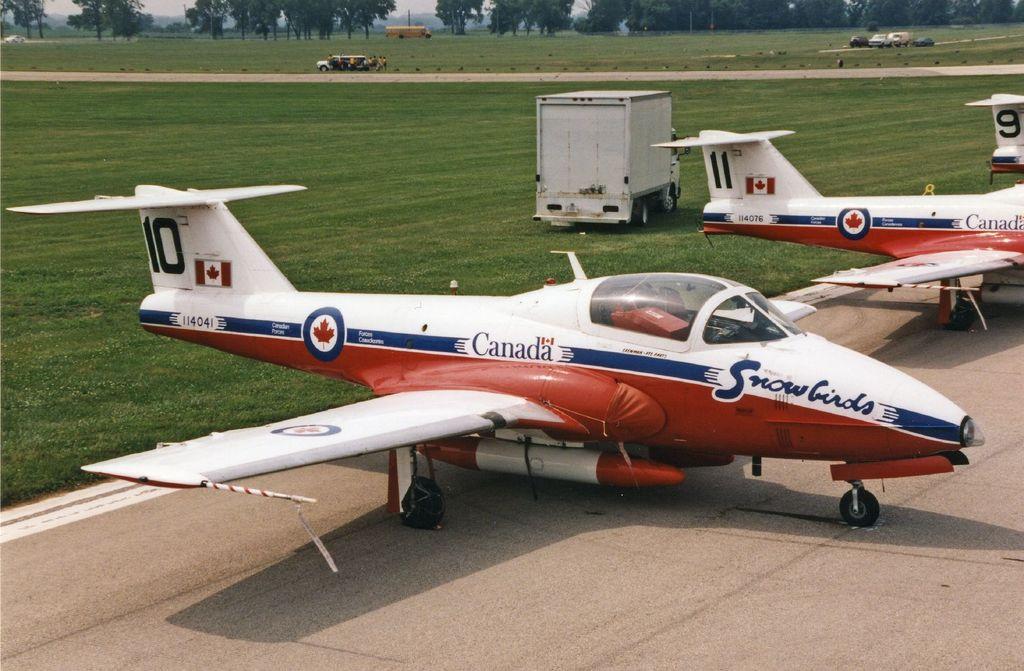What country are these airplanes from?
Your answer should be compact. Canada. What is the number of the closest plane?
Make the answer very short. 10. 